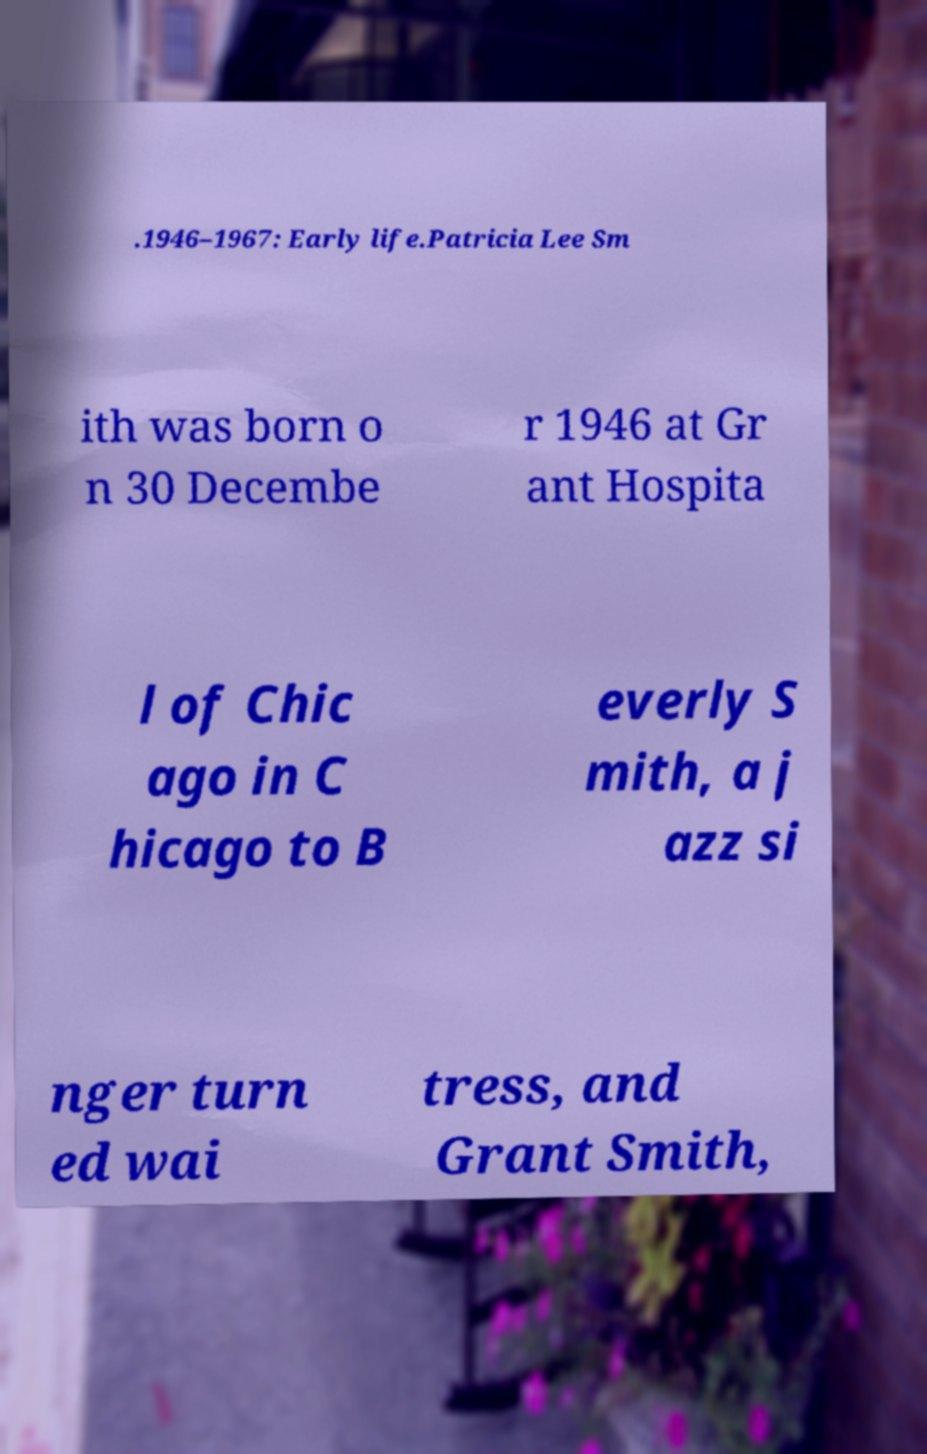What messages or text are displayed in this image? I need them in a readable, typed format. .1946–1967: Early life.Patricia Lee Sm ith was born o n 30 Decembe r 1946 at Gr ant Hospita l of Chic ago in C hicago to B everly S mith, a j azz si nger turn ed wai tress, and Grant Smith, 